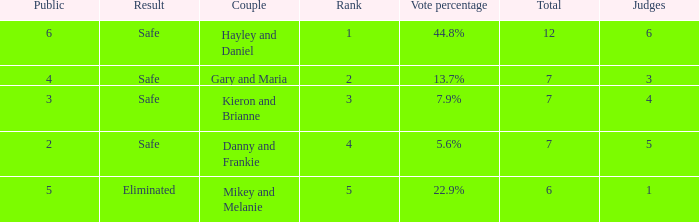How many public is there for the couple that got eliminated? 5.0. 